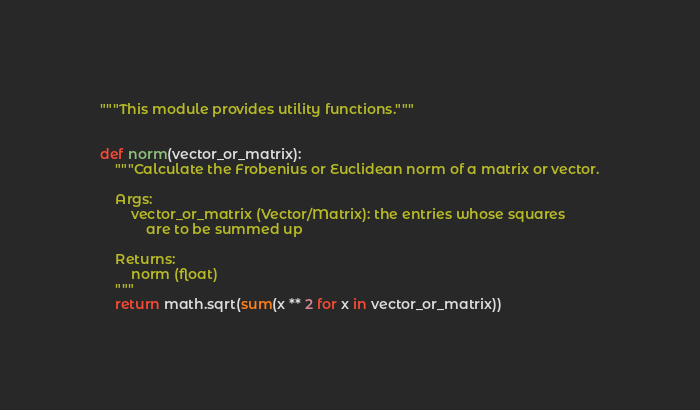Convert code to text. <code><loc_0><loc_0><loc_500><loc_500><_Python_>"""This module provides utility functions."""


def norm(vector_or_matrix):
    """Calculate the Frobenius or Euclidean norm of a matrix or vector.

    Args:
        vector_or_matrix (Vector/Matrix): the entries whose squares
            are to be summed up

    Returns:
        norm (float)
    """
    return math.sqrt(sum(x ** 2 for x in vector_or_matrix))
</code> 